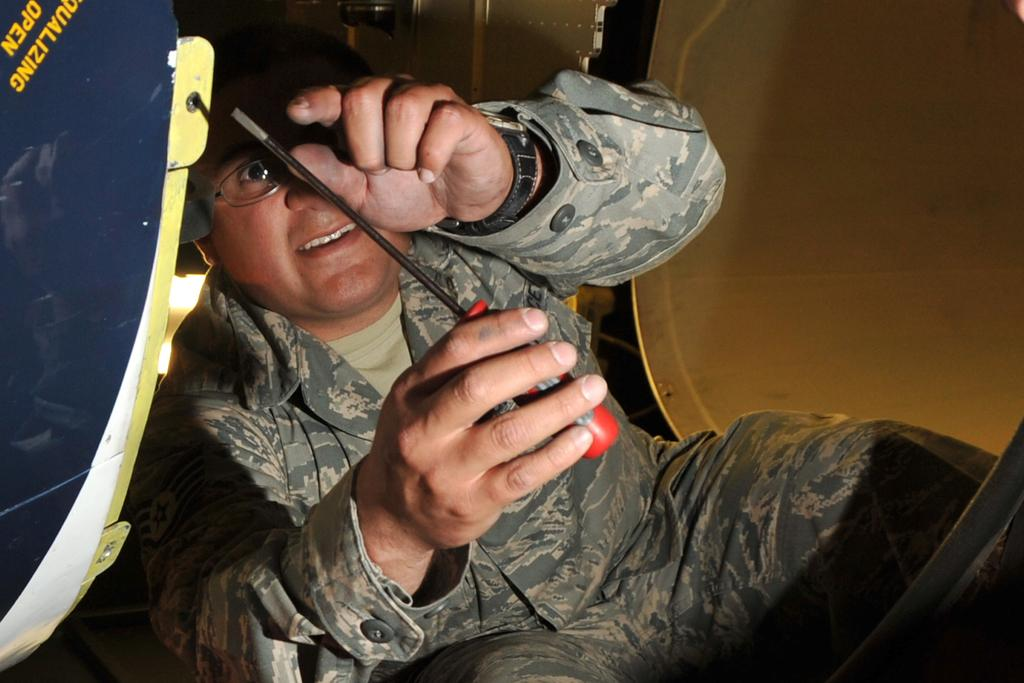What is the main subject of the image? There is a person in the image. What type of clothing is the person wearing? The person is wearing a military uniform. What tool is the person holding? The person is holding a screwdriver. What else can be seen in the image besides the person? There are objects and text visible in the image. How much salt is present in the image? There is no salt visible in the image. What type of spring can be seen in the image? There is no spring present in the image. 